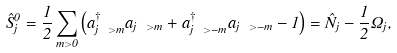Convert formula to latex. <formula><loc_0><loc_0><loc_500><loc_500>\hat { S } ^ { 0 } _ { j } = \frac { 1 } { 2 } \sum _ { m > 0 } \left ( a ^ { \dagger } _ { j \ > m } a _ { j \ > m } + a ^ { \dagger } _ { j \ > - m } a _ { j \ > - m } - 1 \right ) = \hat { N } _ { j } - \frac { 1 } { 2 } \Omega _ { j } ,</formula> 